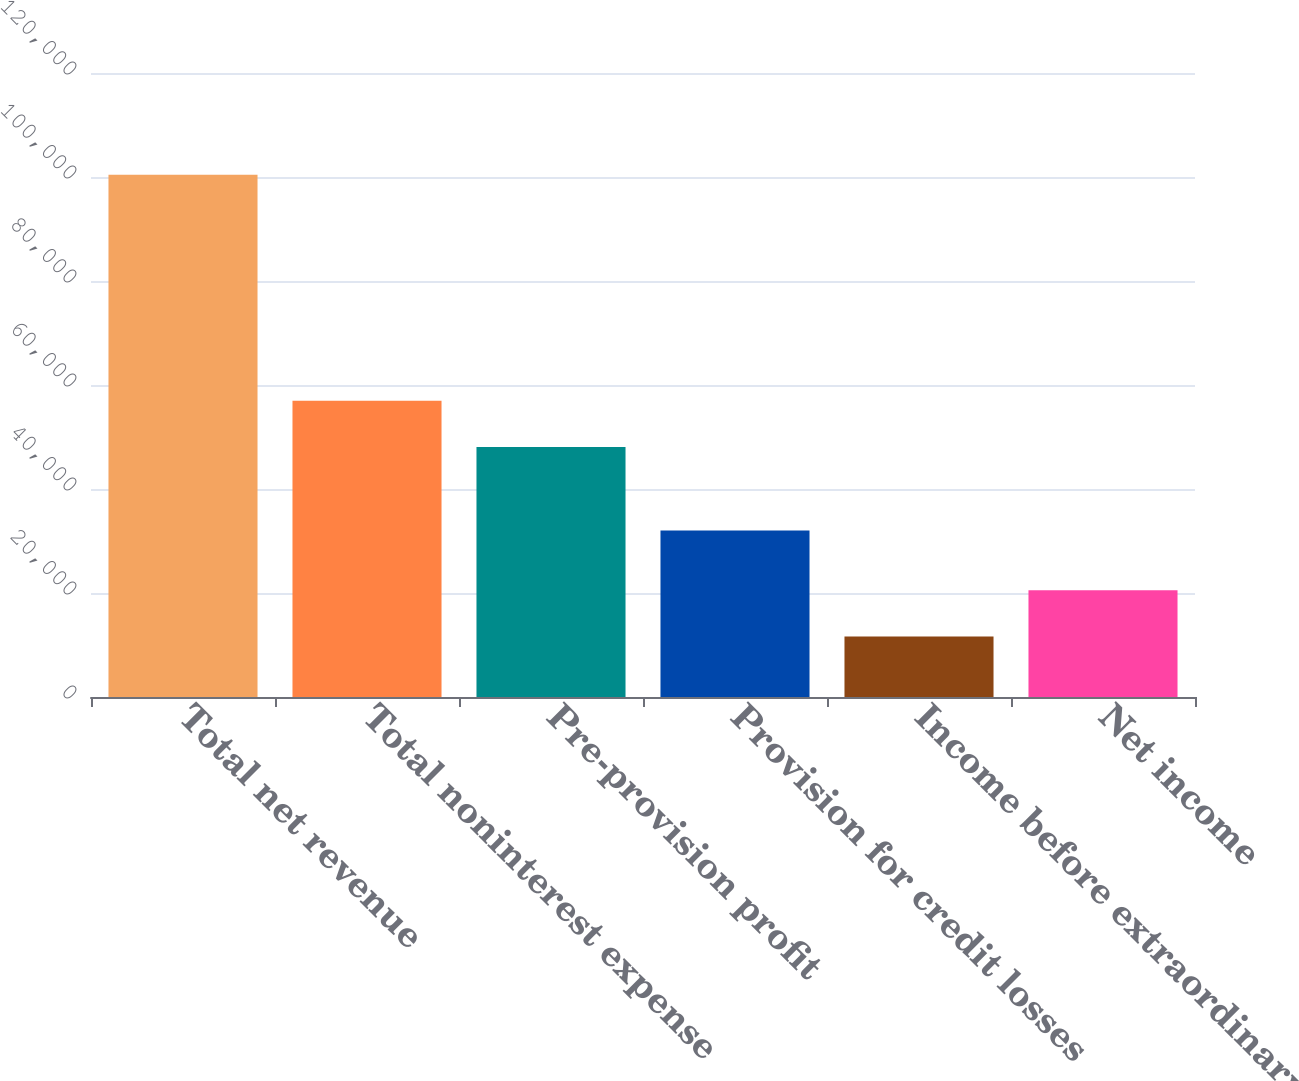<chart> <loc_0><loc_0><loc_500><loc_500><bar_chart><fcel>Total net revenue<fcel>Total noninterest expense<fcel>Pre-provision profit<fcel>Provision for credit losses<fcel>Income before extraordinary<fcel>Net income<nl><fcel>100434<fcel>56960.2<fcel>48082<fcel>32015<fcel>11652<fcel>20530.2<nl></chart> 